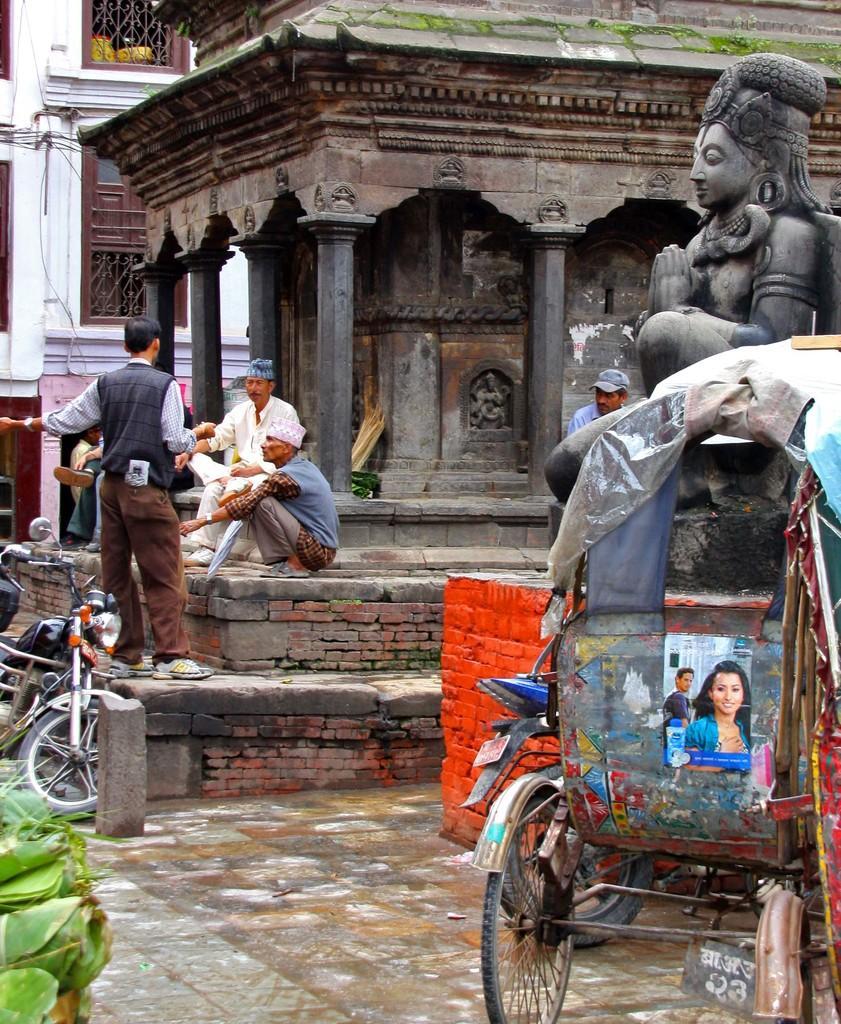In one or two sentences, can you explain what this image depicts? In this image we can see buildings, grills, statues, persons sitting on the pavement, motor vehicles, leaves, floor and a rickshaw. 